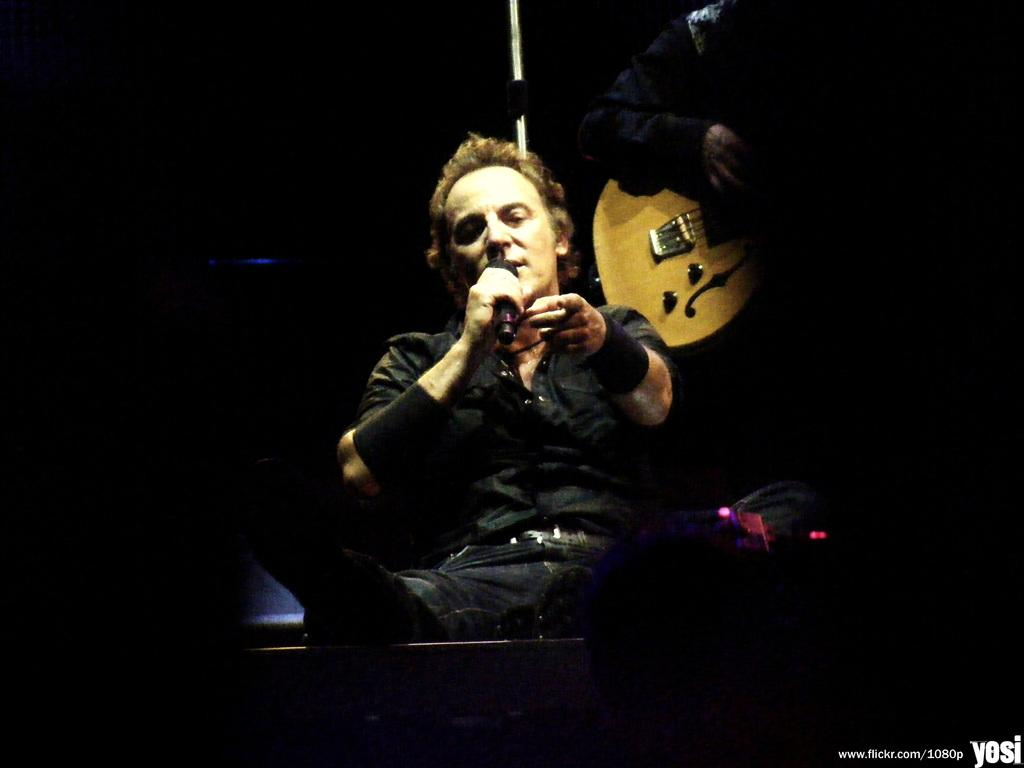What is the person in the image doing? The person is sitting and talking into a microphone. Can you describe the other person in the image? The other person is standing and holding a guitar. What is the lighting condition in the image? The background of the image is dark. How many cherries are on the face of the person holding the guitar? There are no cherries present on the face of the person holding the guitar in the image. 